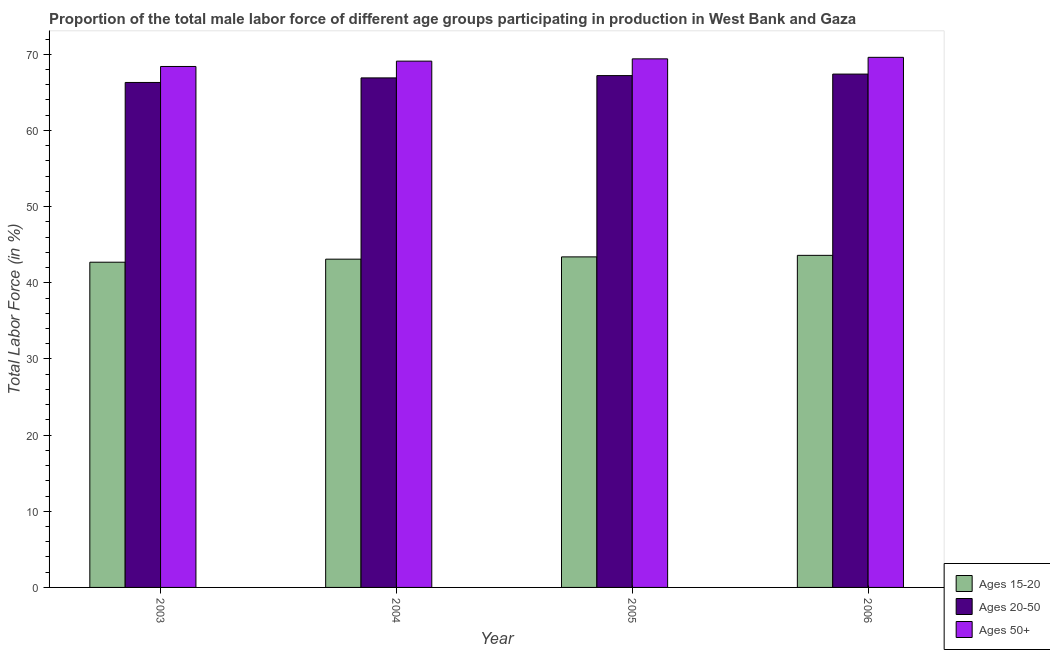How many groups of bars are there?
Offer a terse response. 4. Are the number of bars per tick equal to the number of legend labels?
Your answer should be very brief. Yes. Are the number of bars on each tick of the X-axis equal?
Offer a very short reply. Yes. What is the percentage of male labor force above age 50 in 2004?
Your answer should be very brief. 69.1. Across all years, what is the maximum percentage of male labor force above age 50?
Ensure brevity in your answer.  69.6. Across all years, what is the minimum percentage of male labor force above age 50?
Your response must be concise. 68.4. In which year was the percentage of male labor force within the age group 20-50 maximum?
Ensure brevity in your answer.  2006. In which year was the percentage of male labor force within the age group 20-50 minimum?
Keep it short and to the point. 2003. What is the total percentage of male labor force above age 50 in the graph?
Ensure brevity in your answer.  276.5. What is the difference between the percentage of male labor force within the age group 15-20 in 2003 and that in 2006?
Make the answer very short. -0.9. What is the difference between the percentage of male labor force within the age group 15-20 in 2003 and the percentage of male labor force above age 50 in 2006?
Make the answer very short. -0.9. What is the average percentage of male labor force above age 50 per year?
Make the answer very short. 69.12. In how many years, is the percentage of male labor force above age 50 greater than 16 %?
Provide a short and direct response. 4. What is the ratio of the percentage of male labor force within the age group 20-50 in 2004 to that in 2005?
Give a very brief answer. 1. Is the percentage of male labor force within the age group 15-20 in 2003 less than that in 2005?
Provide a succinct answer. Yes. Is the difference between the percentage of male labor force within the age group 20-50 in 2003 and 2006 greater than the difference between the percentage of male labor force above age 50 in 2003 and 2006?
Provide a succinct answer. No. What is the difference between the highest and the second highest percentage of male labor force above age 50?
Ensure brevity in your answer.  0.2. What is the difference between the highest and the lowest percentage of male labor force above age 50?
Provide a succinct answer. 1.2. What does the 2nd bar from the left in 2004 represents?
Provide a short and direct response. Ages 20-50. What does the 3rd bar from the right in 2003 represents?
Ensure brevity in your answer.  Ages 15-20. Are the values on the major ticks of Y-axis written in scientific E-notation?
Your answer should be very brief. No. Where does the legend appear in the graph?
Make the answer very short. Bottom right. How many legend labels are there?
Your answer should be very brief. 3. How are the legend labels stacked?
Provide a short and direct response. Vertical. What is the title of the graph?
Ensure brevity in your answer.  Proportion of the total male labor force of different age groups participating in production in West Bank and Gaza. Does "Nuclear sources" appear as one of the legend labels in the graph?
Offer a terse response. No. What is the label or title of the Y-axis?
Keep it short and to the point. Total Labor Force (in %). What is the Total Labor Force (in %) of Ages 15-20 in 2003?
Provide a succinct answer. 42.7. What is the Total Labor Force (in %) of Ages 20-50 in 2003?
Make the answer very short. 66.3. What is the Total Labor Force (in %) of Ages 50+ in 2003?
Keep it short and to the point. 68.4. What is the Total Labor Force (in %) in Ages 15-20 in 2004?
Your answer should be compact. 43.1. What is the Total Labor Force (in %) in Ages 20-50 in 2004?
Give a very brief answer. 66.9. What is the Total Labor Force (in %) of Ages 50+ in 2004?
Provide a succinct answer. 69.1. What is the Total Labor Force (in %) in Ages 15-20 in 2005?
Your answer should be very brief. 43.4. What is the Total Labor Force (in %) of Ages 20-50 in 2005?
Your answer should be compact. 67.2. What is the Total Labor Force (in %) of Ages 50+ in 2005?
Provide a succinct answer. 69.4. What is the Total Labor Force (in %) in Ages 15-20 in 2006?
Offer a terse response. 43.6. What is the Total Labor Force (in %) in Ages 20-50 in 2006?
Your answer should be very brief. 67.4. What is the Total Labor Force (in %) of Ages 50+ in 2006?
Ensure brevity in your answer.  69.6. Across all years, what is the maximum Total Labor Force (in %) in Ages 15-20?
Provide a succinct answer. 43.6. Across all years, what is the maximum Total Labor Force (in %) in Ages 20-50?
Your answer should be very brief. 67.4. Across all years, what is the maximum Total Labor Force (in %) of Ages 50+?
Your answer should be very brief. 69.6. Across all years, what is the minimum Total Labor Force (in %) of Ages 15-20?
Make the answer very short. 42.7. Across all years, what is the minimum Total Labor Force (in %) in Ages 20-50?
Provide a short and direct response. 66.3. Across all years, what is the minimum Total Labor Force (in %) of Ages 50+?
Offer a very short reply. 68.4. What is the total Total Labor Force (in %) of Ages 15-20 in the graph?
Offer a terse response. 172.8. What is the total Total Labor Force (in %) of Ages 20-50 in the graph?
Provide a short and direct response. 267.8. What is the total Total Labor Force (in %) of Ages 50+ in the graph?
Your answer should be very brief. 276.5. What is the difference between the Total Labor Force (in %) in Ages 15-20 in 2003 and that in 2004?
Make the answer very short. -0.4. What is the difference between the Total Labor Force (in %) in Ages 20-50 in 2003 and that in 2005?
Provide a short and direct response. -0.9. What is the difference between the Total Labor Force (in %) of Ages 20-50 in 2003 and that in 2006?
Keep it short and to the point. -1.1. What is the difference between the Total Labor Force (in %) of Ages 50+ in 2004 and that in 2006?
Give a very brief answer. -0.5. What is the difference between the Total Labor Force (in %) in Ages 15-20 in 2003 and the Total Labor Force (in %) in Ages 20-50 in 2004?
Give a very brief answer. -24.2. What is the difference between the Total Labor Force (in %) in Ages 15-20 in 2003 and the Total Labor Force (in %) in Ages 50+ in 2004?
Give a very brief answer. -26.4. What is the difference between the Total Labor Force (in %) of Ages 15-20 in 2003 and the Total Labor Force (in %) of Ages 20-50 in 2005?
Give a very brief answer. -24.5. What is the difference between the Total Labor Force (in %) of Ages 15-20 in 2003 and the Total Labor Force (in %) of Ages 50+ in 2005?
Your response must be concise. -26.7. What is the difference between the Total Labor Force (in %) of Ages 15-20 in 2003 and the Total Labor Force (in %) of Ages 20-50 in 2006?
Your answer should be very brief. -24.7. What is the difference between the Total Labor Force (in %) in Ages 15-20 in 2003 and the Total Labor Force (in %) in Ages 50+ in 2006?
Your answer should be very brief. -26.9. What is the difference between the Total Labor Force (in %) in Ages 20-50 in 2003 and the Total Labor Force (in %) in Ages 50+ in 2006?
Keep it short and to the point. -3.3. What is the difference between the Total Labor Force (in %) of Ages 15-20 in 2004 and the Total Labor Force (in %) of Ages 20-50 in 2005?
Offer a very short reply. -24.1. What is the difference between the Total Labor Force (in %) of Ages 15-20 in 2004 and the Total Labor Force (in %) of Ages 50+ in 2005?
Your answer should be compact. -26.3. What is the difference between the Total Labor Force (in %) in Ages 15-20 in 2004 and the Total Labor Force (in %) in Ages 20-50 in 2006?
Give a very brief answer. -24.3. What is the difference between the Total Labor Force (in %) in Ages 15-20 in 2004 and the Total Labor Force (in %) in Ages 50+ in 2006?
Give a very brief answer. -26.5. What is the difference between the Total Labor Force (in %) of Ages 20-50 in 2004 and the Total Labor Force (in %) of Ages 50+ in 2006?
Give a very brief answer. -2.7. What is the difference between the Total Labor Force (in %) of Ages 15-20 in 2005 and the Total Labor Force (in %) of Ages 50+ in 2006?
Provide a short and direct response. -26.2. What is the difference between the Total Labor Force (in %) of Ages 20-50 in 2005 and the Total Labor Force (in %) of Ages 50+ in 2006?
Offer a terse response. -2.4. What is the average Total Labor Force (in %) in Ages 15-20 per year?
Keep it short and to the point. 43.2. What is the average Total Labor Force (in %) in Ages 20-50 per year?
Your answer should be very brief. 66.95. What is the average Total Labor Force (in %) of Ages 50+ per year?
Keep it short and to the point. 69.12. In the year 2003, what is the difference between the Total Labor Force (in %) of Ages 15-20 and Total Labor Force (in %) of Ages 20-50?
Provide a succinct answer. -23.6. In the year 2003, what is the difference between the Total Labor Force (in %) in Ages 15-20 and Total Labor Force (in %) in Ages 50+?
Keep it short and to the point. -25.7. In the year 2003, what is the difference between the Total Labor Force (in %) of Ages 20-50 and Total Labor Force (in %) of Ages 50+?
Provide a short and direct response. -2.1. In the year 2004, what is the difference between the Total Labor Force (in %) of Ages 15-20 and Total Labor Force (in %) of Ages 20-50?
Offer a very short reply. -23.8. In the year 2005, what is the difference between the Total Labor Force (in %) in Ages 15-20 and Total Labor Force (in %) in Ages 20-50?
Your response must be concise. -23.8. In the year 2005, what is the difference between the Total Labor Force (in %) of Ages 15-20 and Total Labor Force (in %) of Ages 50+?
Your answer should be compact. -26. In the year 2006, what is the difference between the Total Labor Force (in %) in Ages 15-20 and Total Labor Force (in %) in Ages 20-50?
Your answer should be very brief. -23.8. In the year 2006, what is the difference between the Total Labor Force (in %) of Ages 15-20 and Total Labor Force (in %) of Ages 50+?
Keep it short and to the point. -26. What is the ratio of the Total Labor Force (in %) of Ages 20-50 in 2003 to that in 2004?
Your answer should be compact. 0.99. What is the ratio of the Total Labor Force (in %) of Ages 50+ in 2003 to that in 2004?
Offer a terse response. 0.99. What is the ratio of the Total Labor Force (in %) in Ages 15-20 in 2003 to that in 2005?
Provide a short and direct response. 0.98. What is the ratio of the Total Labor Force (in %) of Ages 20-50 in 2003 to that in 2005?
Provide a succinct answer. 0.99. What is the ratio of the Total Labor Force (in %) in Ages 50+ in 2003 to that in 2005?
Your response must be concise. 0.99. What is the ratio of the Total Labor Force (in %) in Ages 15-20 in 2003 to that in 2006?
Make the answer very short. 0.98. What is the ratio of the Total Labor Force (in %) of Ages 20-50 in 2003 to that in 2006?
Make the answer very short. 0.98. What is the ratio of the Total Labor Force (in %) of Ages 50+ in 2003 to that in 2006?
Offer a very short reply. 0.98. What is the ratio of the Total Labor Force (in %) of Ages 15-20 in 2004 to that in 2005?
Provide a short and direct response. 0.99. What is the ratio of the Total Labor Force (in %) of Ages 20-50 in 2004 to that in 2005?
Your response must be concise. 1. What is the ratio of the Total Labor Force (in %) in Ages 50+ in 2004 to that in 2005?
Your response must be concise. 1. What is the ratio of the Total Labor Force (in %) of Ages 50+ in 2004 to that in 2006?
Keep it short and to the point. 0.99. What is the ratio of the Total Labor Force (in %) of Ages 15-20 in 2005 to that in 2006?
Make the answer very short. 1. What is the ratio of the Total Labor Force (in %) in Ages 20-50 in 2005 to that in 2006?
Provide a succinct answer. 1. What is the difference between the highest and the second highest Total Labor Force (in %) in Ages 15-20?
Your response must be concise. 0.2. What is the difference between the highest and the lowest Total Labor Force (in %) of Ages 20-50?
Ensure brevity in your answer.  1.1. 